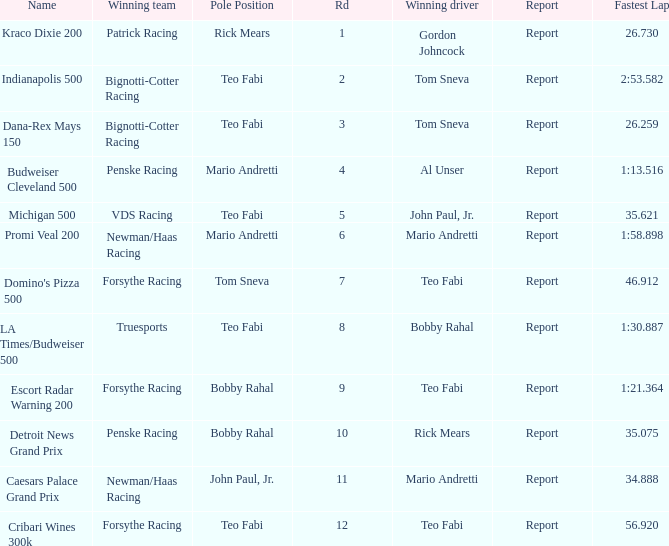What is the highest Rd that Tom Sneva had the pole position in? 7.0. 